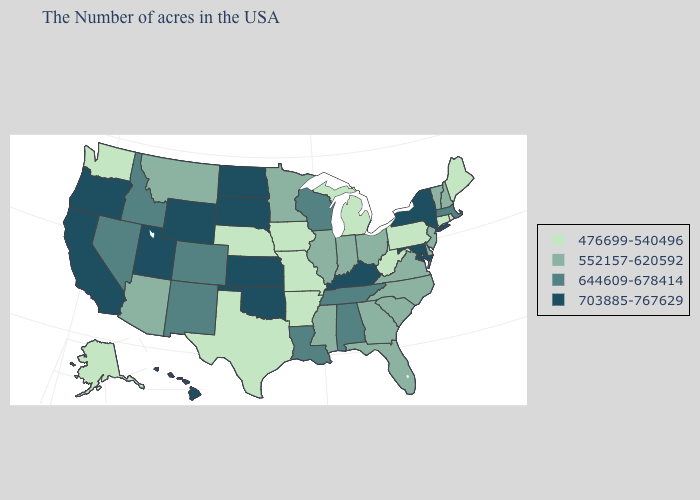What is the value of Rhode Island?
Give a very brief answer. 476699-540496. Does the first symbol in the legend represent the smallest category?
Concise answer only. Yes. What is the value of Kansas?
Be succinct. 703885-767629. Name the states that have a value in the range 703885-767629?
Short answer required. New York, Maryland, Kentucky, Kansas, Oklahoma, South Dakota, North Dakota, Wyoming, Utah, California, Oregon, Hawaii. Does West Virginia have the lowest value in the South?
Quick response, please. Yes. Does South Dakota have the highest value in the MidWest?
Be succinct. Yes. Which states hav the highest value in the South?
Quick response, please. Maryland, Kentucky, Oklahoma. What is the value of Washington?
Short answer required. 476699-540496. Name the states that have a value in the range 703885-767629?
Concise answer only. New York, Maryland, Kentucky, Kansas, Oklahoma, South Dakota, North Dakota, Wyoming, Utah, California, Oregon, Hawaii. What is the value of Indiana?
Concise answer only. 552157-620592. Does Delaware have the same value as Missouri?
Keep it brief. No. Name the states that have a value in the range 476699-540496?
Give a very brief answer. Maine, Rhode Island, Connecticut, Pennsylvania, West Virginia, Michigan, Missouri, Arkansas, Iowa, Nebraska, Texas, Washington, Alaska. Name the states that have a value in the range 703885-767629?
Quick response, please. New York, Maryland, Kentucky, Kansas, Oklahoma, South Dakota, North Dakota, Wyoming, Utah, California, Oregon, Hawaii. What is the value of North Carolina?
Quick response, please. 552157-620592. Which states have the lowest value in the South?
Keep it brief. West Virginia, Arkansas, Texas. 